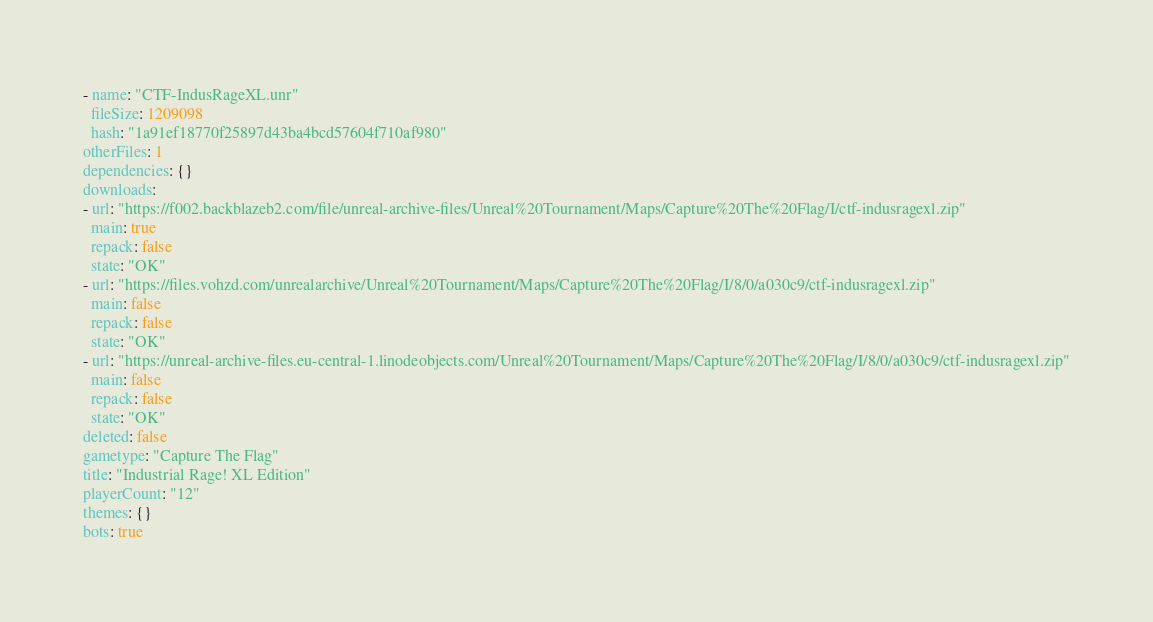Convert code to text. <code><loc_0><loc_0><loc_500><loc_500><_YAML_>- name: "CTF-IndusRageXL.unr"
  fileSize: 1209098
  hash: "1a91ef18770f25897d43ba4bcd57604f710af980"
otherFiles: 1
dependencies: {}
downloads:
- url: "https://f002.backblazeb2.com/file/unreal-archive-files/Unreal%20Tournament/Maps/Capture%20The%20Flag/I/ctf-indusragexl.zip"
  main: true
  repack: false
  state: "OK"
- url: "https://files.vohzd.com/unrealarchive/Unreal%20Tournament/Maps/Capture%20The%20Flag/I/8/0/a030c9/ctf-indusragexl.zip"
  main: false
  repack: false
  state: "OK"
- url: "https://unreal-archive-files.eu-central-1.linodeobjects.com/Unreal%20Tournament/Maps/Capture%20The%20Flag/I/8/0/a030c9/ctf-indusragexl.zip"
  main: false
  repack: false
  state: "OK"
deleted: false
gametype: "Capture The Flag"
title: "Industrial Rage! XL Edition"
playerCount: "12"
themes: {}
bots: true
</code> 